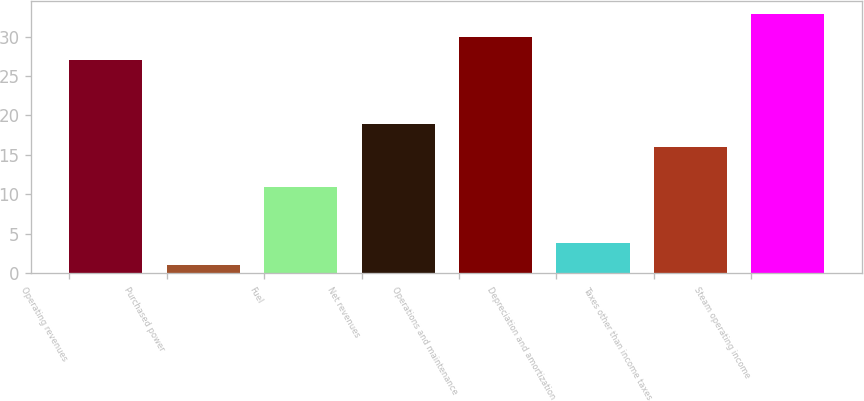Convert chart to OTSL. <chart><loc_0><loc_0><loc_500><loc_500><bar_chart><fcel>Operating revenues<fcel>Purchased power<fcel>Fuel<fcel>Net revenues<fcel>Operations and maintenance<fcel>Depreciation and amortization<fcel>Taxes other than income taxes<fcel>Steam operating income<nl><fcel>27<fcel>1<fcel>11<fcel>18.9<fcel>30<fcel>3.9<fcel>16<fcel>32.9<nl></chart> 